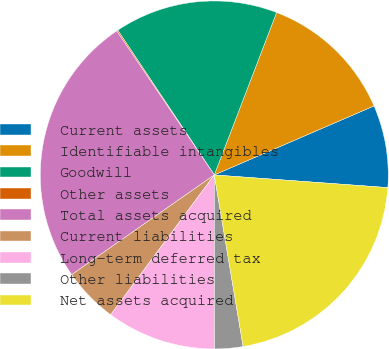<chart> <loc_0><loc_0><loc_500><loc_500><pie_chart><fcel>Current assets<fcel>Identifiable intangibles<fcel>Goodwill<fcel>Other assets<fcel>Total assets acquired<fcel>Current liabilities<fcel>Long-term deferred tax<fcel>Other liabilities<fcel>Net assets acquired<nl><fcel>7.65%<fcel>12.68%<fcel>15.19%<fcel>0.12%<fcel>25.23%<fcel>5.14%<fcel>10.17%<fcel>2.63%<fcel>21.19%<nl></chart> 